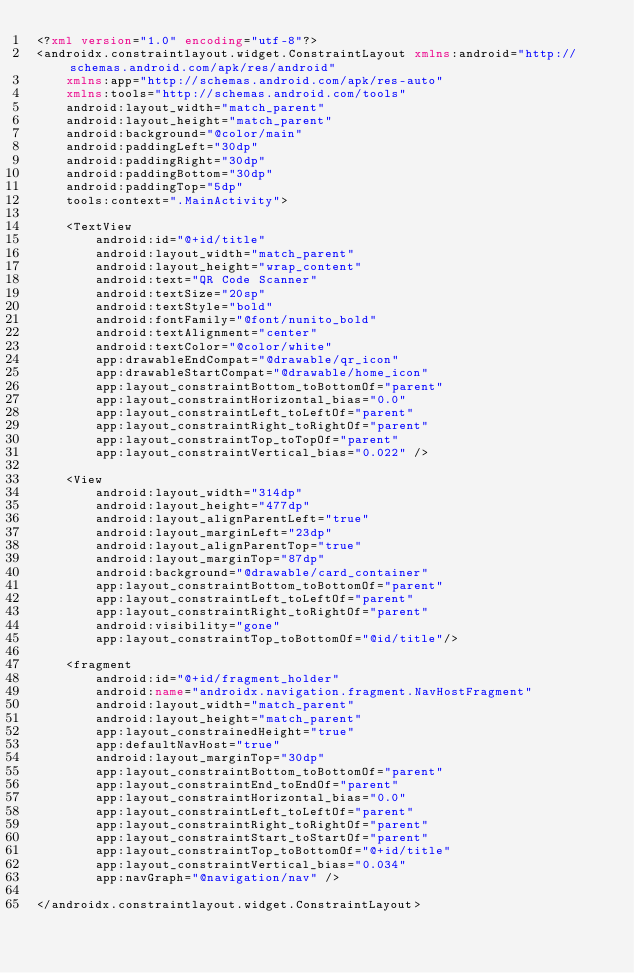Convert code to text. <code><loc_0><loc_0><loc_500><loc_500><_XML_><?xml version="1.0" encoding="utf-8"?>
<androidx.constraintlayout.widget.ConstraintLayout xmlns:android="http://schemas.android.com/apk/res/android"
    xmlns:app="http://schemas.android.com/apk/res-auto"
    xmlns:tools="http://schemas.android.com/tools"
    android:layout_width="match_parent"
    android:layout_height="match_parent"
    android:background="@color/main"
    android:paddingLeft="30dp"
    android:paddingRight="30dp"
    android:paddingBottom="30dp"
    android:paddingTop="5dp"
    tools:context=".MainActivity">

    <TextView
        android:id="@+id/title"
        android:layout_width="match_parent"
        android:layout_height="wrap_content"
        android:text="QR Code Scanner"
        android:textSize="20sp"
        android:textStyle="bold"
        android:fontFamily="@font/nunito_bold"
        android:textAlignment="center"
        android:textColor="@color/white"
        app:drawableEndCompat="@drawable/qr_icon"
        app:drawableStartCompat="@drawable/home_icon"
        app:layout_constraintBottom_toBottomOf="parent"
        app:layout_constraintHorizontal_bias="0.0"
        app:layout_constraintLeft_toLeftOf="parent"
        app:layout_constraintRight_toRightOf="parent"
        app:layout_constraintTop_toTopOf="parent"
        app:layout_constraintVertical_bias="0.022" />

    <View
        android:layout_width="314dp"
        android:layout_height="477dp"
        android:layout_alignParentLeft="true"
        android:layout_marginLeft="23dp"
        android:layout_alignParentTop="true"
        android:layout_marginTop="87dp"
        android:background="@drawable/card_container"
        app:layout_constraintBottom_toBottomOf="parent"
        app:layout_constraintLeft_toLeftOf="parent"
        app:layout_constraintRight_toRightOf="parent"
        android:visibility="gone"
        app:layout_constraintTop_toBottomOf="@id/title"/>

    <fragment
        android:id="@+id/fragment_holder"
        android:name="androidx.navigation.fragment.NavHostFragment"
        android:layout_width="match_parent"
        android:layout_height="match_parent"
        app:layout_constrainedHeight="true"
        app:defaultNavHost="true"
        android:layout_marginTop="30dp"
        app:layout_constraintBottom_toBottomOf="parent"
        app:layout_constraintEnd_toEndOf="parent"
        app:layout_constraintHorizontal_bias="0.0"
        app:layout_constraintLeft_toLeftOf="parent"
        app:layout_constraintRight_toRightOf="parent"
        app:layout_constraintStart_toStartOf="parent"
        app:layout_constraintTop_toBottomOf="@+id/title"
        app:layout_constraintVertical_bias="0.034"
        app:navGraph="@navigation/nav" />

</androidx.constraintlayout.widget.ConstraintLayout></code> 